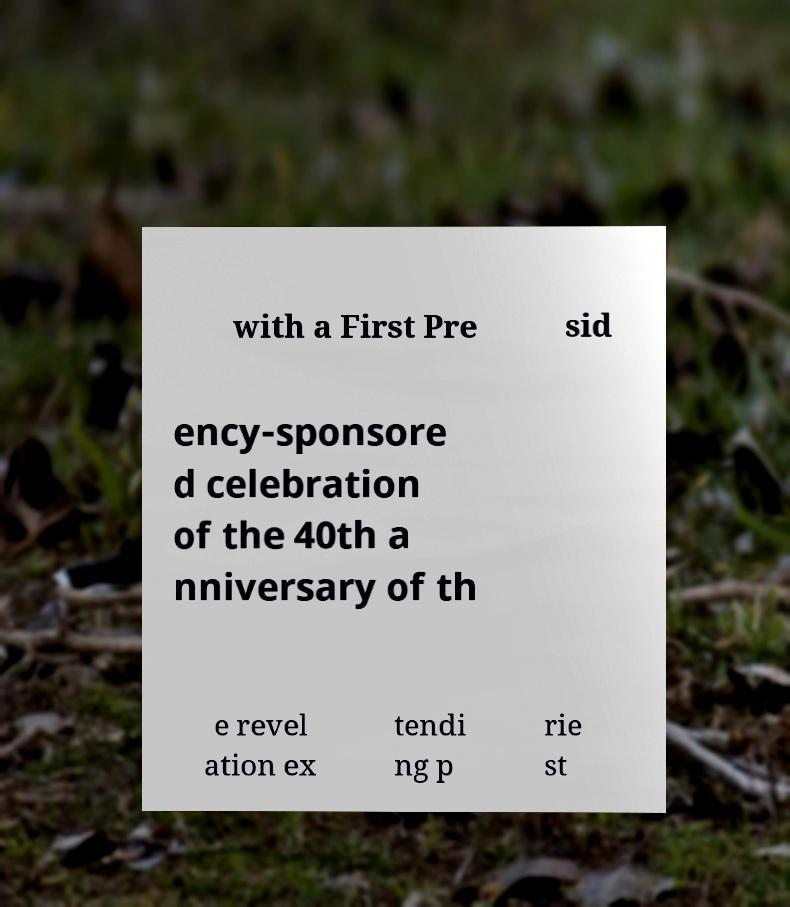Could you assist in decoding the text presented in this image and type it out clearly? with a First Pre sid ency-sponsore d celebration of the 40th a nniversary of th e revel ation ex tendi ng p rie st 